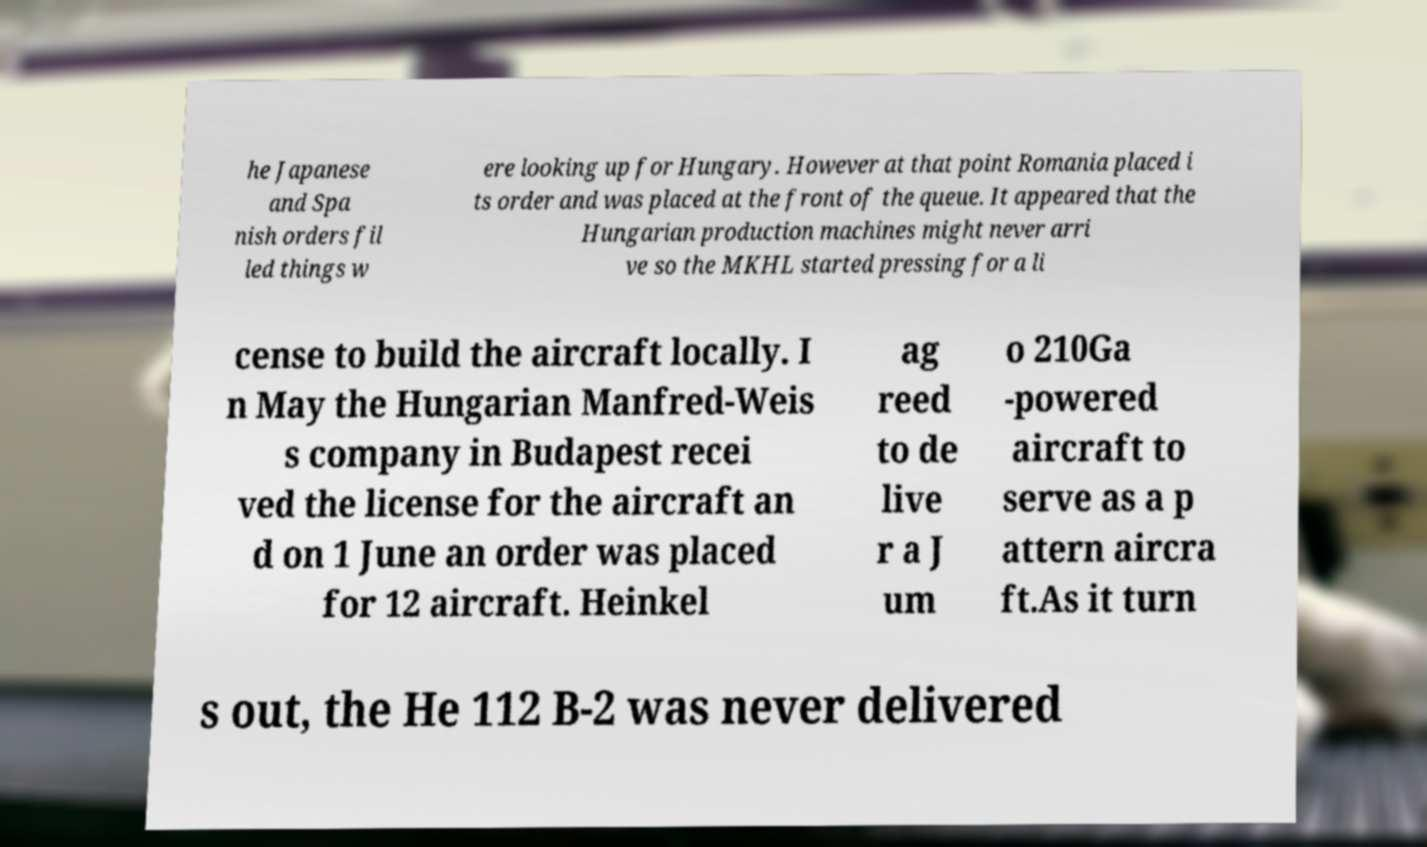For documentation purposes, I need the text within this image transcribed. Could you provide that? he Japanese and Spa nish orders fil led things w ere looking up for Hungary. However at that point Romania placed i ts order and was placed at the front of the queue. It appeared that the Hungarian production machines might never arri ve so the MKHL started pressing for a li cense to build the aircraft locally. I n May the Hungarian Manfred-Weis s company in Budapest recei ved the license for the aircraft an d on 1 June an order was placed for 12 aircraft. Heinkel ag reed to de live r a J um o 210Ga -powered aircraft to serve as a p attern aircra ft.As it turn s out, the He 112 B-2 was never delivered 